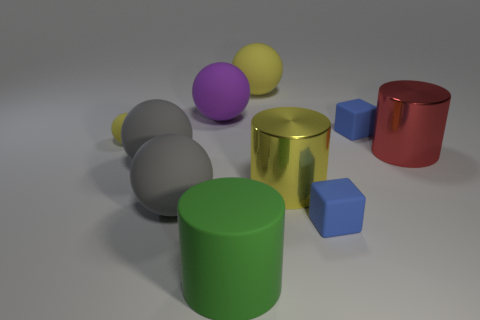Subtract all gray spheres. How many spheres are left? 3 Subtract all large matte cylinders. How many cylinders are left? 2 Subtract 0 cyan blocks. How many objects are left? 10 Subtract all blocks. How many objects are left? 8 Subtract 2 blocks. How many blocks are left? 0 Subtract all green cubes. Subtract all brown cylinders. How many cubes are left? 2 Subtract all cyan cylinders. How many yellow spheres are left? 2 Subtract all tiny yellow things. Subtract all large cylinders. How many objects are left? 6 Add 5 tiny yellow objects. How many tiny yellow objects are left? 6 Add 1 yellow balls. How many yellow balls exist? 3 